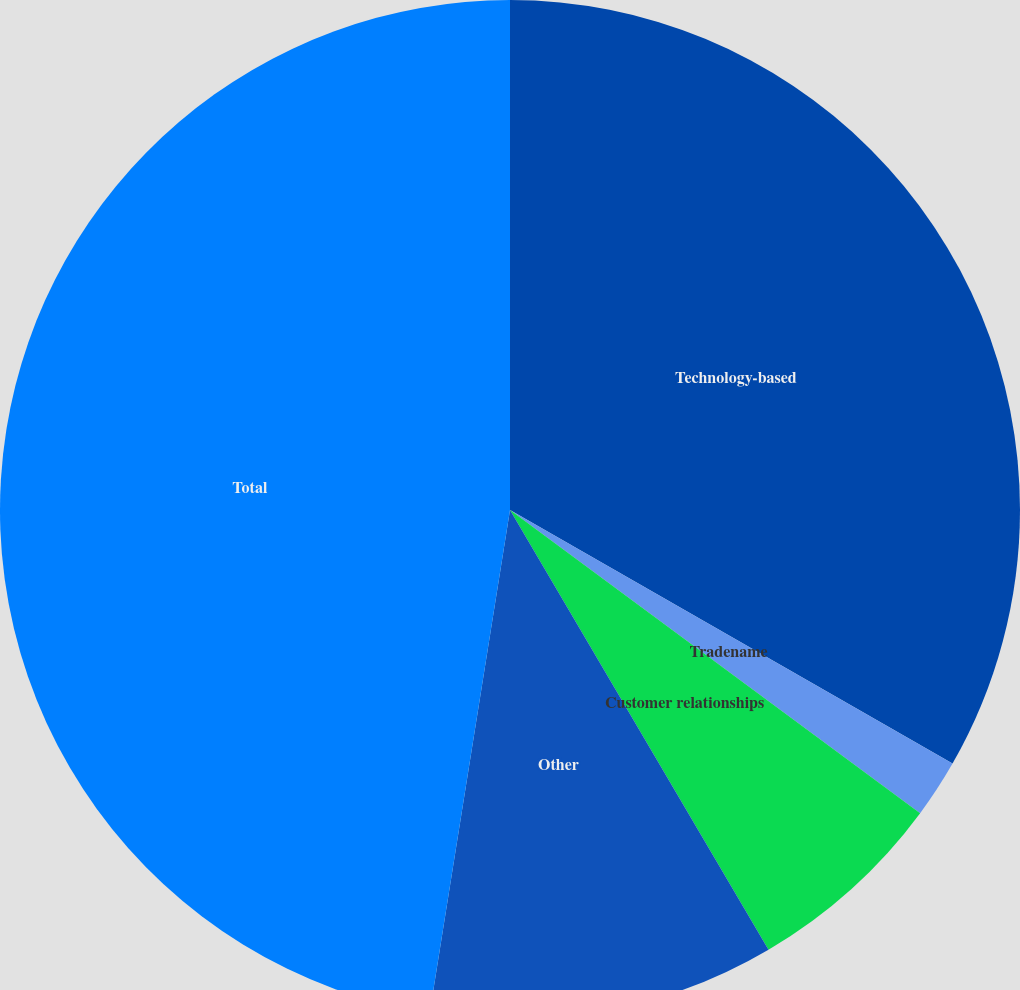Convert chart to OTSL. <chart><loc_0><loc_0><loc_500><loc_500><pie_chart><fcel>Technology-based<fcel>Tradename<fcel>Customer relationships<fcel>Other<fcel>Total<nl><fcel>33.28%<fcel>1.85%<fcel>6.41%<fcel>10.98%<fcel>47.48%<nl></chart> 